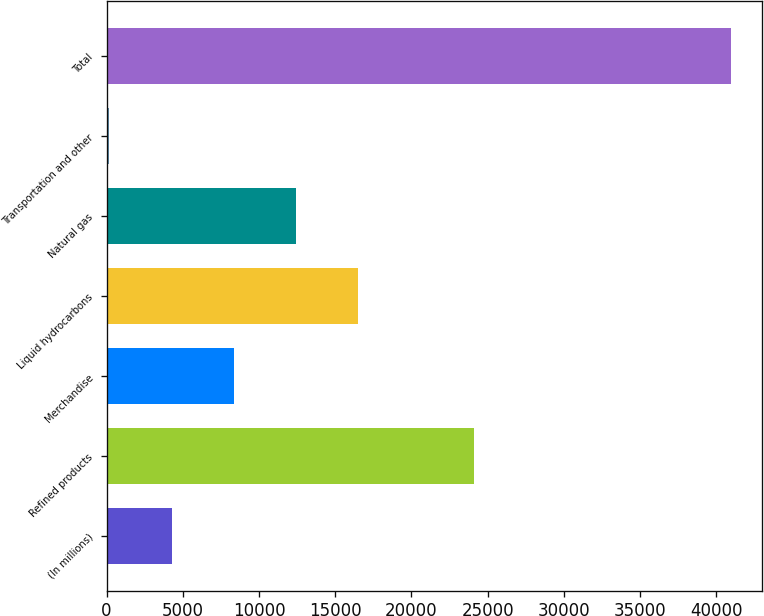Convert chart. <chart><loc_0><loc_0><loc_500><loc_500><bar_chart><fcel>(In millions)<fcel>Refined products<fcel>Merchandise<fcel>Liquid hydrocarbons<fcel>Natural gas<fcel>Transportation and other<fcel>Total<nl><fcel>4258.3<fcel>24092<fcel>8336.6<fcel>16493.2<fcel>12414.9<fcel>180<fcel>40963<nl></chart> 